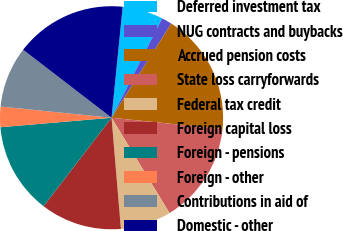<chart> <loc_0><loc_0><loc_500><loc_500><pie_chart><fcel>Deferred investment tax<fcel>NUG contracts and buybacks<fcel>Accrued pension costs<fcel>State loss carryforwards<fcel>Federal tax credit<fcel>Foreign capital loss<fcel>Foreign - pensions<fcel>Foreign - other<fcel>Contributions in aid of<fcel>Domestic - other<nl><fcel>5.9%<fcel>1.5%<fcel>17.62%<fcel>14.69%<fcel>7.36%<fcel>11.76%<fcel>13.22%<fcel>2.96%<fcel>8.83%<fcel>16.16%<nl></chart> 